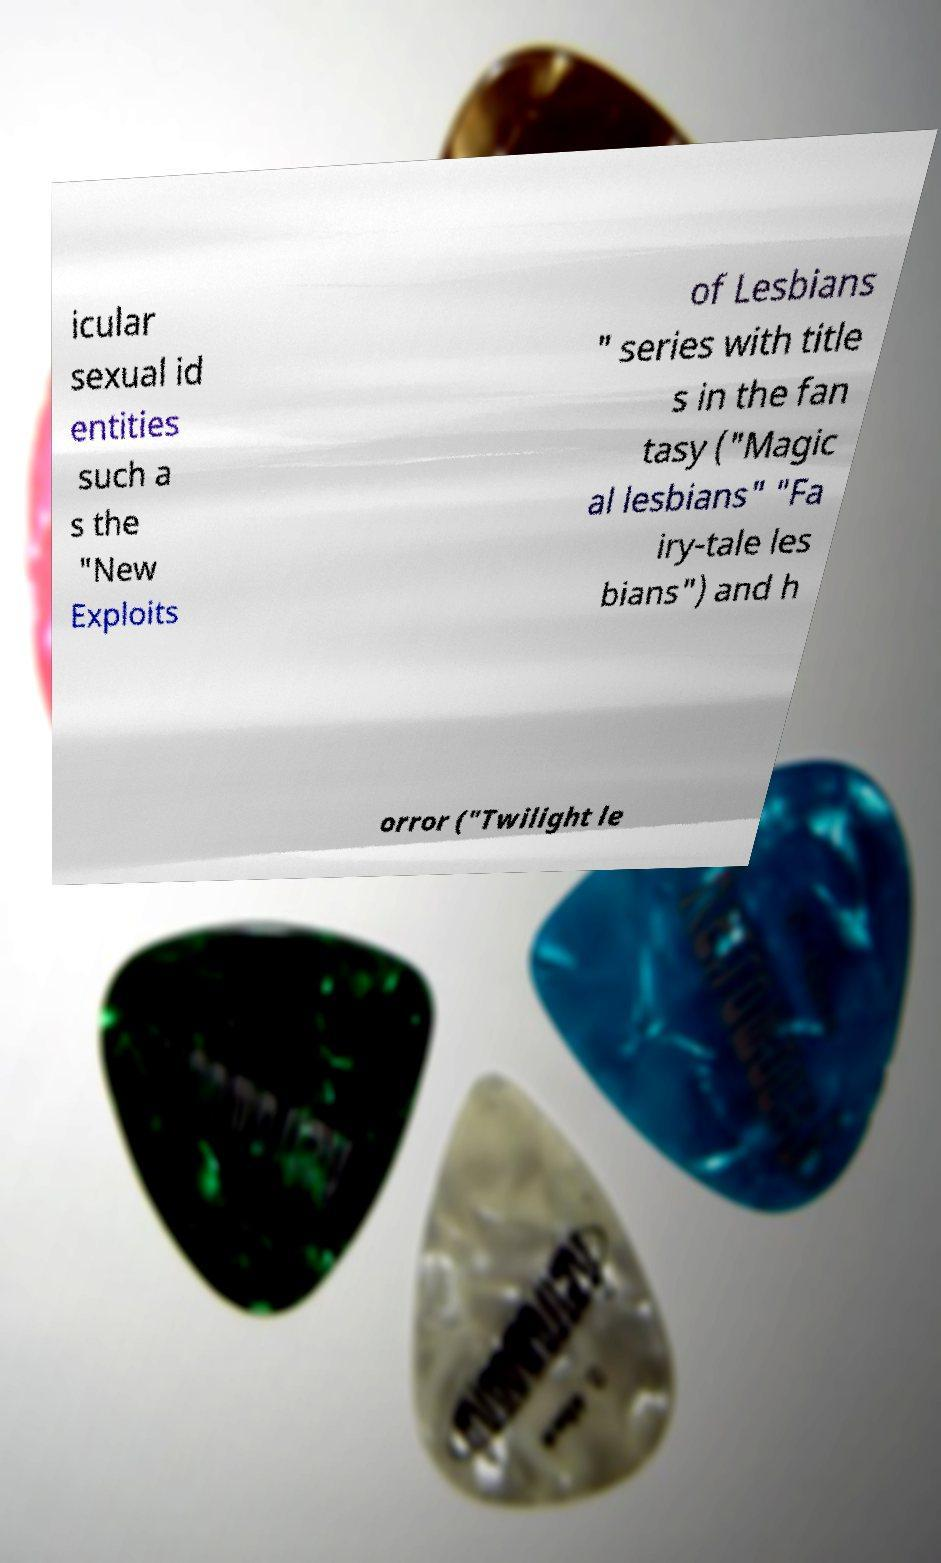For documentation purposes, I need the text within this image transcribed. Could you provide that? icular sexual id entities such a s the "New Exploits of Lesbians " series with title s in the fan tasy ("Magic al lesbians" "Fa iry-tale les bians") and h orror ("Twilight le 